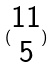Convert formula to latex. <formula><loc_0><loc_0><loc_500><loc_500>( \begin{matrix} 1 1 \\ 5 \end{matrix} )</formula> 